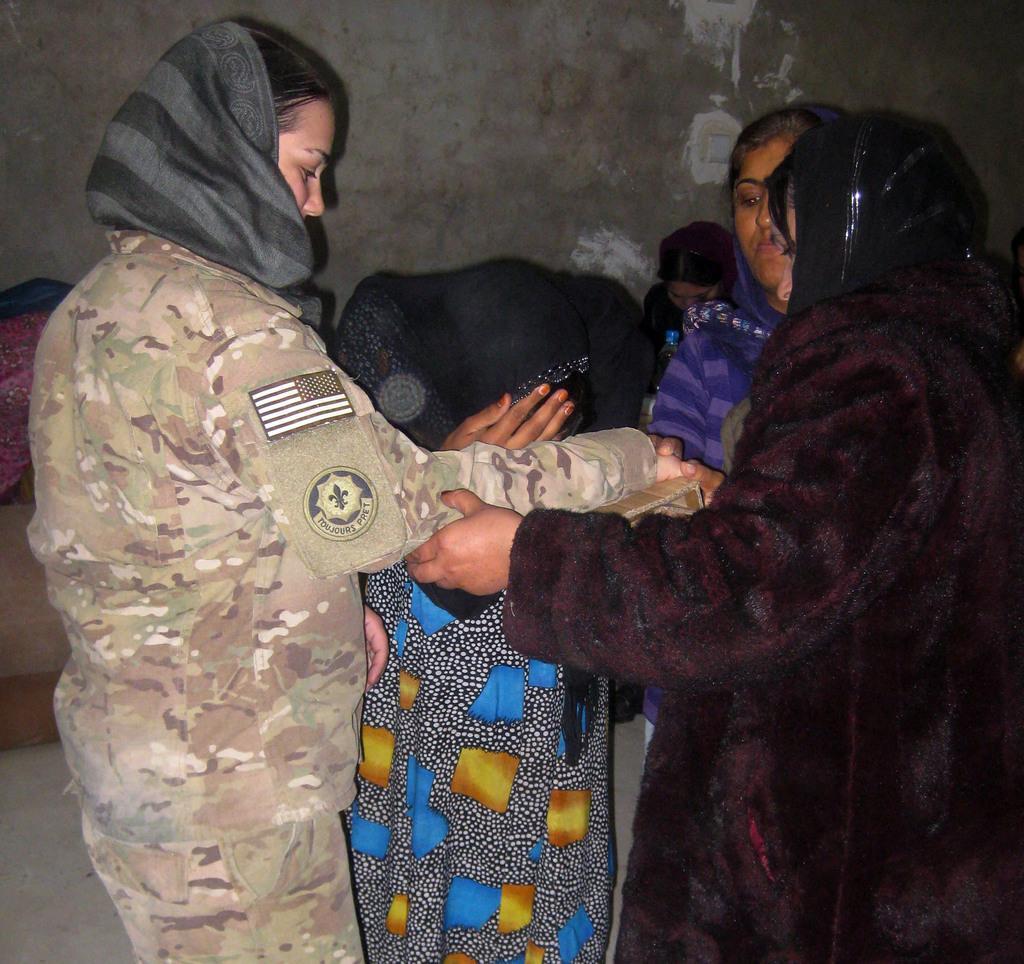In one or two sentences, can you explain what this image depicts? In this image there are some people who are standing, and in the background there is a wall and some clothes and table. At the bottom there is floor. 